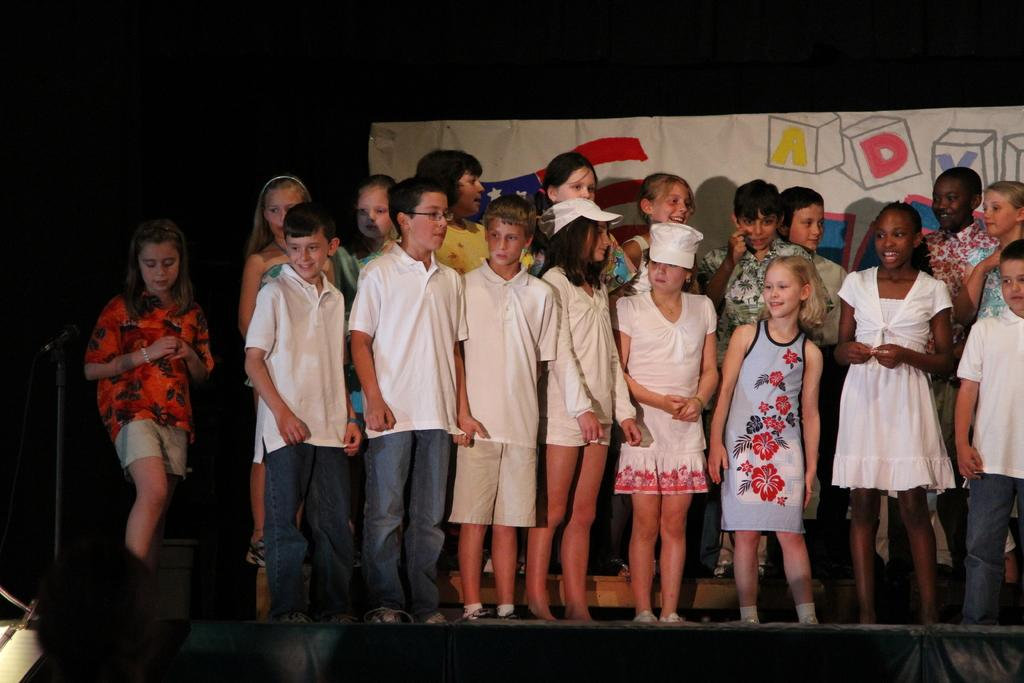What are the kids in the image doing? The kids are standing on the stage. Can you describe the appearance of the kids in the middle of the image? Two kids in the middle of the image are wearing caps. What can be seen on the left side of the image? There is a microphone stand on the left side of the image. What is visible in the background of the image? There is a banner in the background of the image. Can you tell me how many clovers are on the stage in the image? There are no clovers visible in the image; it features kids standing on a stage. What type of vegetable is being used as a prop by the kids on the stage? There is no vegetable present in the image; the kids are not holding any props. 